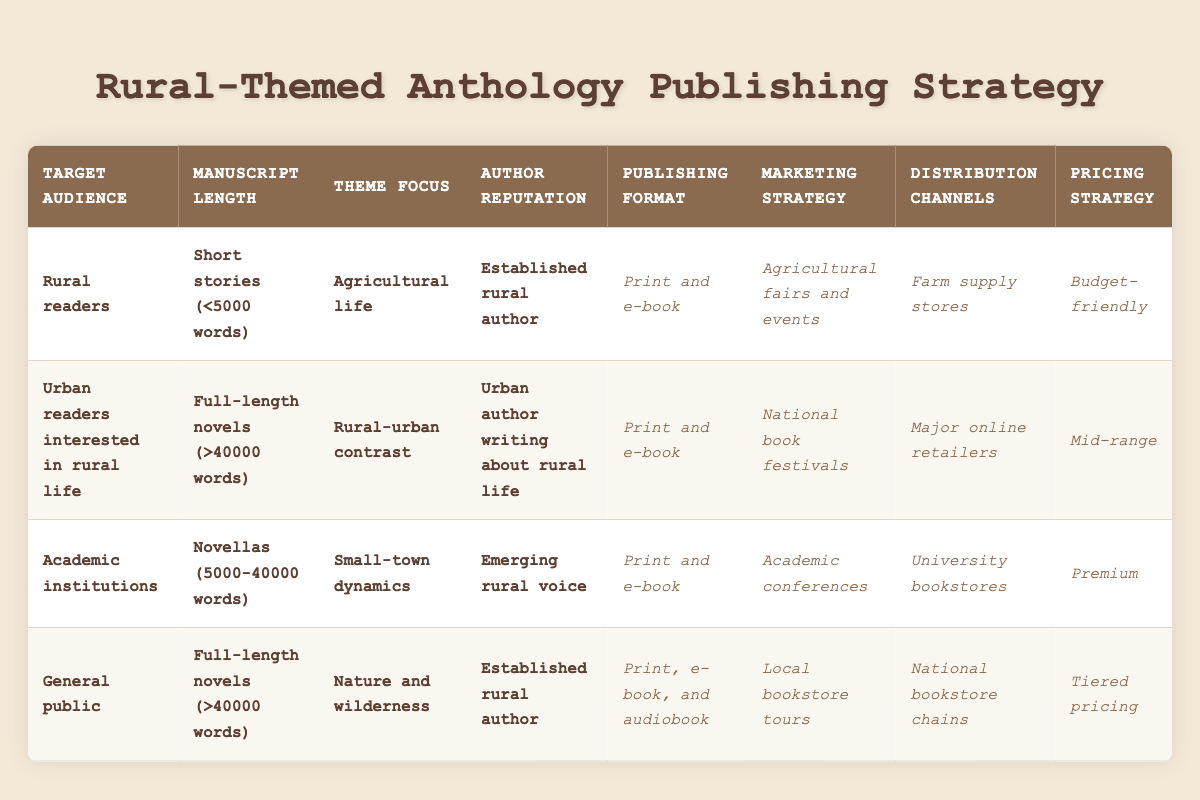What is the publishing format for manuscripts targeting rural readers with a theme focused on agricultural life? According to the table, for the target audience of rural readers and the theme focus on agricultural life, the publishing format recommended is "Print and e-book."
Answer: Print and e-book Which marketing strategy is chosen for urban readers interested in rural life who write full-length novels? The table specifies that the marketing strategy for urban readers interested in rural life who write full-length novels (over 40,000 words) focusing on rural-urban contrast is "National book festivals."
Answer: National book festivals True or False: Emerging rural voices targeting academic institutions should have a premium pricing strategy. The table confirms that if the target audience is academic institutions with an emerging rural voice and the manuscript length is novellas (5,000 to 40,000 words), then the pricing strategy should indeed be "Premium."
Answer: True What is the common feature in the publishing formats for both established rural authors and the general public? Both established rural authors and the general public have their manuscripts published in "Print and e-book." For the general public, it also includes audiobook format, but the print and e-book are common.
Answer: Print and e-book For manuscripts that are full-length novels aimed at the general public with a focus on nature and wilderness, what distribution channel is recommended? The table indicates that the distribution channel for full-length novels targeting the general public with a theme of nature and wilderness is "National bookstore chains."
Answer: National bookstore chains What is the total number of unique marketing strategies listed in the table? By examining the marketing strategies outlined for each of the rules, we find five unique strategies: Agricultural fairs and events, National book festivals, Academic conferences, Local bookstore tours, and Online rural community forums. Thus, the count is five.
Answer: Five What is the pricing strategy for novellas focused on small-town dynamics by an emerging rural voice? The table states that for novellas focused on small-town dynamics with an emerging rural voice, the chosen pricing strategy is "Premium."
Answer: Premium If one were to compare the pricing strategies of all target audiences, which one has the budget-friendly option? The table shows that only the target audience of rural readers with a manuscript of short stories on agricultural life has the pricing strategy of "Budget-friendly."
Answer: Budget-friendly 